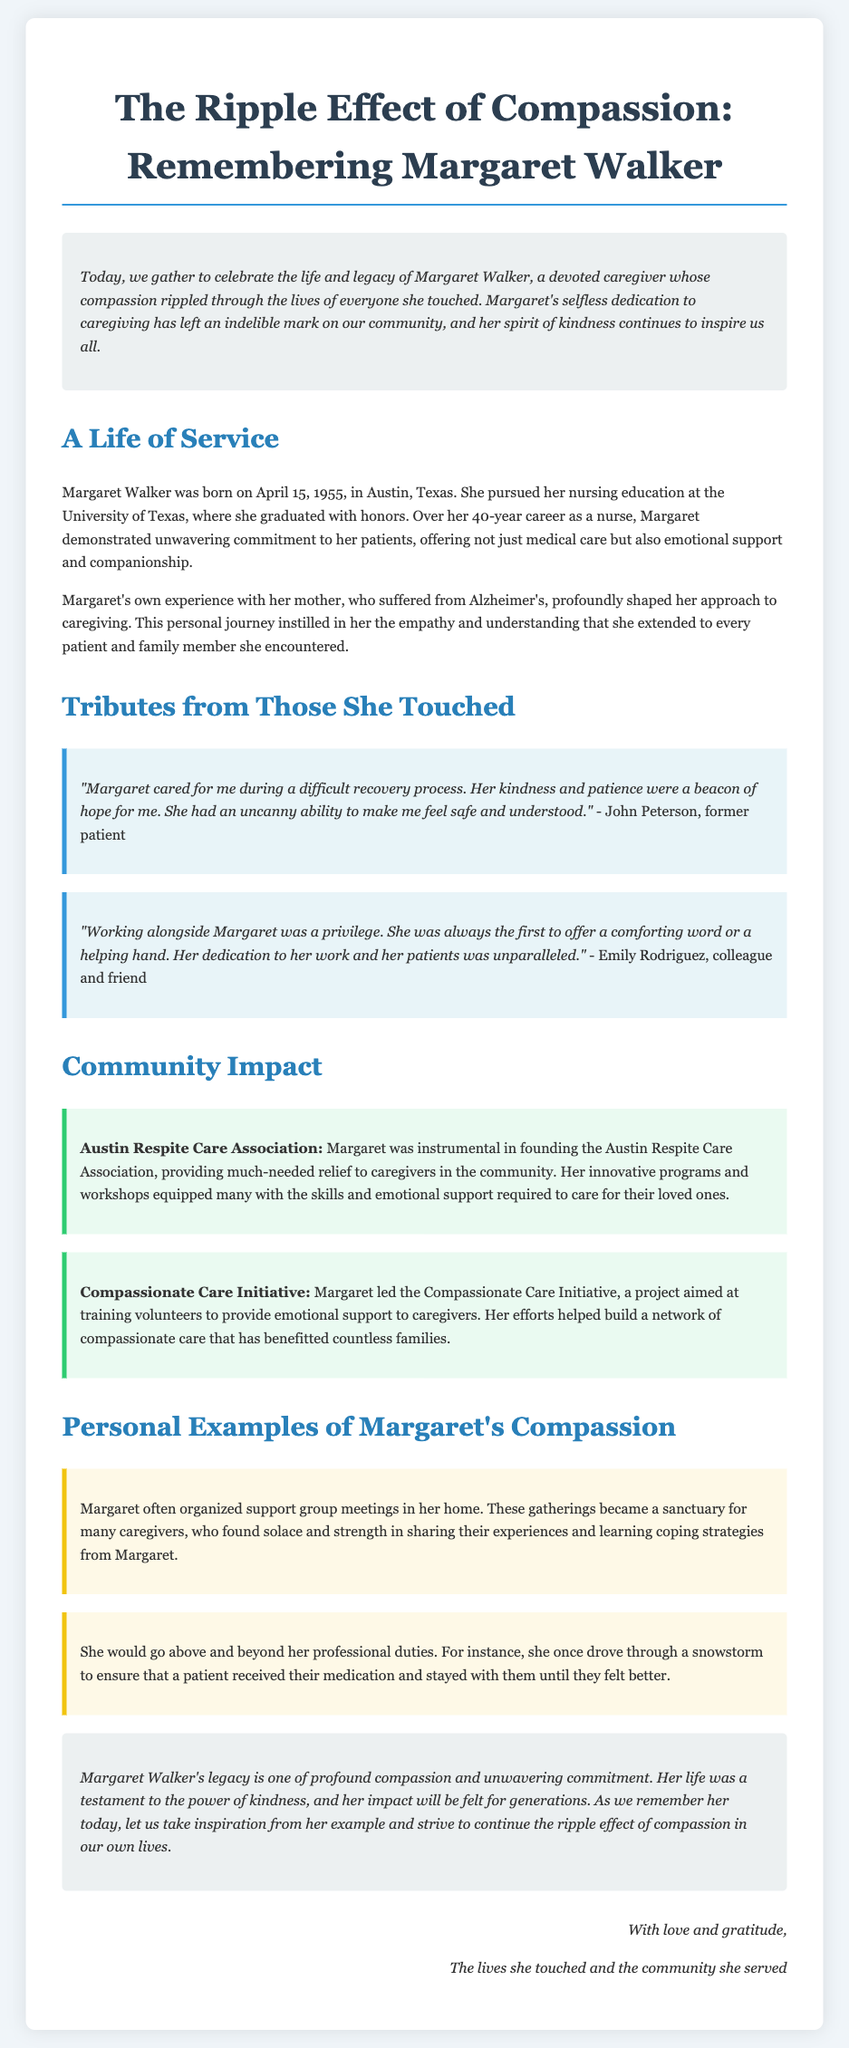what was the birth date of Margaret Walker? Margaret Walker was born on April 15, 1955, as stated in the document.
Answer: April 15, 1955 what notable initiative did Margaret Walker lead? The document mentions that Margaret led the Compassionate Care Initiative.
Answer: Compassionate Care Initiative who described Margaret's care as a "beacon of hope"? The document indicates that John Peterson referred to Margaret's care this way.
Answer: John Peterson how long was Margaret's nursing career? Margaret had a 40-year career as a nurse, according to the document.
Answer: 40 years what city was Margaret Walker born in? The document specifies that Margaret Walker was born in Austin, Texas.
Answer: Austin, Texas what type of support did Margaret provide during support group meetings? The document indicates that caregivers found solace and strength in sharing experiences at these meetings.
Answer: Solace and strength what did Margaret do during a snowstorm for a patient? The document describes that she drove through a snowstorm to ensure a patient received their medication.
Answer: Drove through a snowstorm what was one effect of the Austin Respite Care Association? The document states that it provided much-needed relief to caregivers in the community.
Answer: Relief to caregivers what is a significant trait of Margaret Walker as mentioned in the eulogy? The eulogy highlights her profound compassion as a significant trait.
Answer: Compassion 